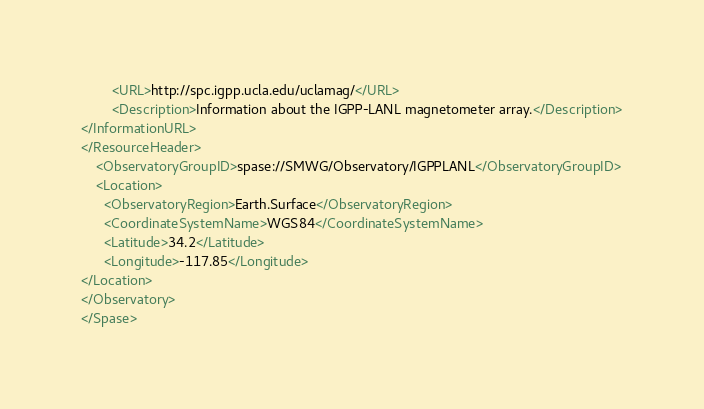<code> <loc_0><loc_0><loc_500><loc_500><_XML_>        <URL>http://spc.igpp.ucla.edu/uclamag/</URL>
        <Description>Information about the IGPP-LANL magnetometer array.</Description>
</InformationURL>
</ResourceHeader>
    <ObservatoryGroupID>spase://SMWG/Observatory/IGPPLANL</ObservatoryGroupID>
    <Location>
      <ObservatoryRegion>Earth.Surface</ObservatoryRegion>
      <CoordinateSystemName>WGS84</CoordinateSystemName>
      <Latitude>34.2</Latitude>
      <Longitude>-117.85</Longitude>
</Location>
</Observatory>
</Spase>
</code> 